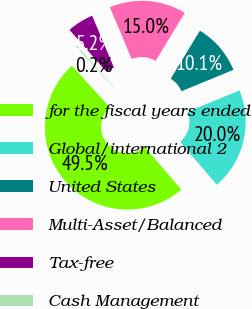<chart> <loc_0><loc_0><loc_500><loc_500><pie_chart><fcel>for the fiscal years ended<fcel>Global/international 2<fcel>United States<fcel>Multi-Asset/Balanced<fcel>Tax-free<fcel>Cash Management<nl><fcel>49.51%<fcel>19.95%<fcel>10.1%<fcel>15.02%<fcel>5.17%<fcel>0.25%<nl></chart> 